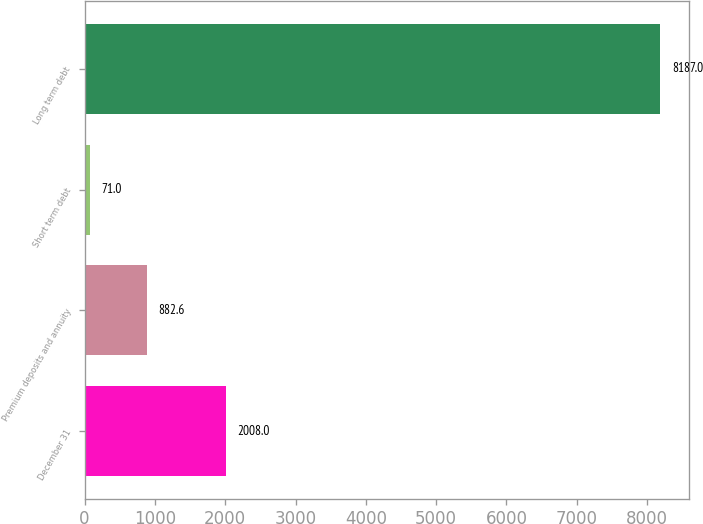<chart> <loc_0><loc_0><loc_500><loc_500><bar_chart><fcel>December 31<fcel>Premium deposits and annuity<fcel>Short term debt<fcel>Long term debt<nl><fcel>2008<fcel>882.6<fcel>71<fcel>8187<nl></chart> 